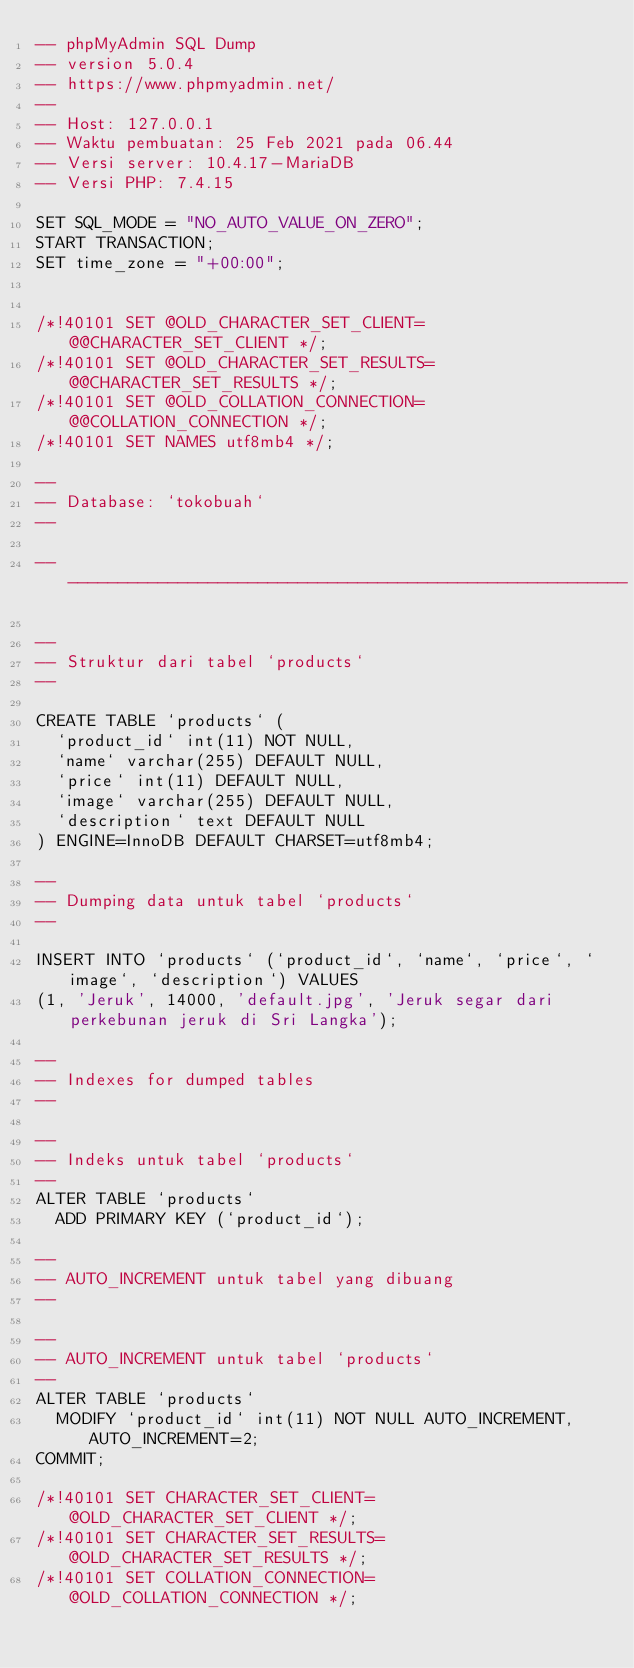Convert code to text. <code><loc_0><loc_0><loc_500><loc_500><_SQL_>-- phpMyAdmin SQL Dump
-- version 5.0.4
-- https://www.phpmyadmin.net/
--
-- Host: 127.0.0.1
-- Waktu pembuatan: 25 Feb 2021 pada 06.44
-- Versi server: 10.4.17-MariaDB
-- Versi PHP: 7.4.15

SET SQL_MODE = "NO_AUTO_VALUE_ON_ZERO";
START TRANSACTION;
SET time_zone = "+00:00";


/*!40101 SET @OLD_CHARACTER_SET_CLIENT=@@CHARACTER_SET_CLIENT */;
/*!40101 SET @OLD_CHARACTER_SET_RESULTS=@@CHARACTER_SET_RESULTS */;
/*!40101 SET @OLD_COLLATION_CONNECTION=@@COLLATION_CONNECTION */;
/*!40101 SET NAMES utf8mb4 */;

--
-- Database: `tokobuah`
--

-- --------------------------------------------------------

--
-- Struktur dari tabel `products`
--

CREATE TABLE `products` (
  `product_id` int(11) NOT NULL,
  `name` varchar(255) DEFAULT NULL,
  `price` int(11) DEFAULT NULL,
  `image` varchar(255) DEFAULT NULL,
  `description` text DEFAULT NULL
) ENGINE=InnoDB DEFAULT CHARSET=utf8mb4;

--
-- Dumping data untuk tabel `products`
--

INSERT INTO `products` (`product_id`, `name`, `price`, `image`, `description`) VALUES
(1, 'Jeruk', 14000, 'default.jpg', 'Jeruk segar dari perkebunan jeruk di Sri Langka');

--
-- Indexes for dumped tables
--

--
-- Indeks untuk tabel `products`
--
ALTER TABLE `products`
  ADD PRIMARY KEY (`product_id`);

--
-- AUTO_INCREMENT untuk tabel yang dibuang
--

--
-- AUTO_INCREMENT untuk tabel `products`
--
ALTER TABLE `products`
  MODIFY `product_id` int(11) NOT NULL AUTO_INCREMENT, AUTO_INCREMENT=2;
COMMIT;

/*!40101 SET CHARACTER_SET_CLIENT=@OLD_CHARACTER_SET_CLIENT */;
/*!40101 SET CHARACTER_SET_RESULTS=@OLD_CHARACTER_SET_RESULTS */;
/*!40101 SET COLLATION_CONNECTION=@OLD_COLLATION_CONNECTION */;
</code> 